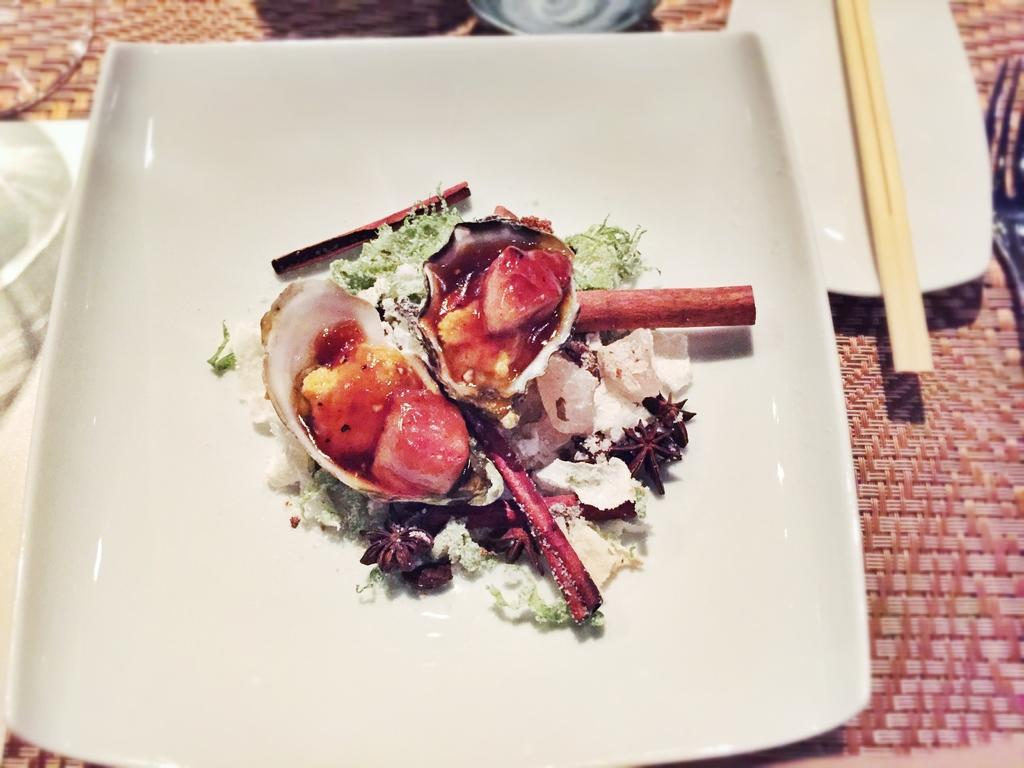What is the main object in the image? There is a food item in the image. How is the food item placed? The food item is kept on a plate. What utensil is present in the image? There are chopsticks in the image. How are the chopsticks placed? The chopsticks are kept on another plate. Where are the plates with the food item and chopsticks placed? The plates are placed on a table. What type of nut is being cracked by the squirrel in the image? There is no squirrel or nut present in the image. 